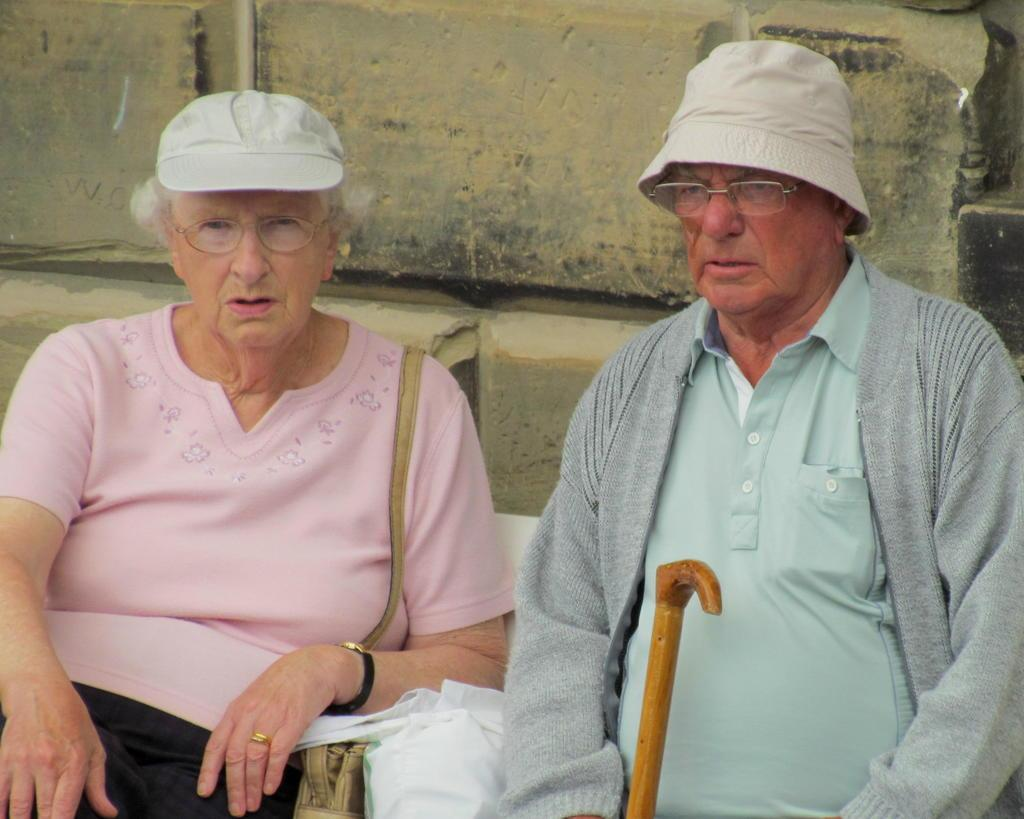How many people are present in the image? There are two people, a man and a woman, present in the image. What is the man holding in the image? The man is holding a stick. What else can be seen in the image besides the people? Baggage is visible in the image. What verse is the fireman reciting in the image? There is no fireman present in the image, nor is anyone reciting a verse. Can you see any feathers in the image? There are no feathers visible in the image. 